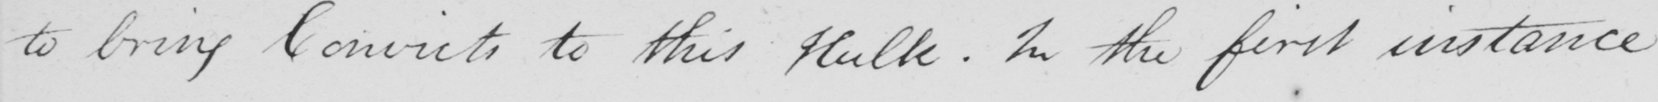Please transcribe the handwritten text in this image. to bring Convicts to this Hulk . In the first instance 